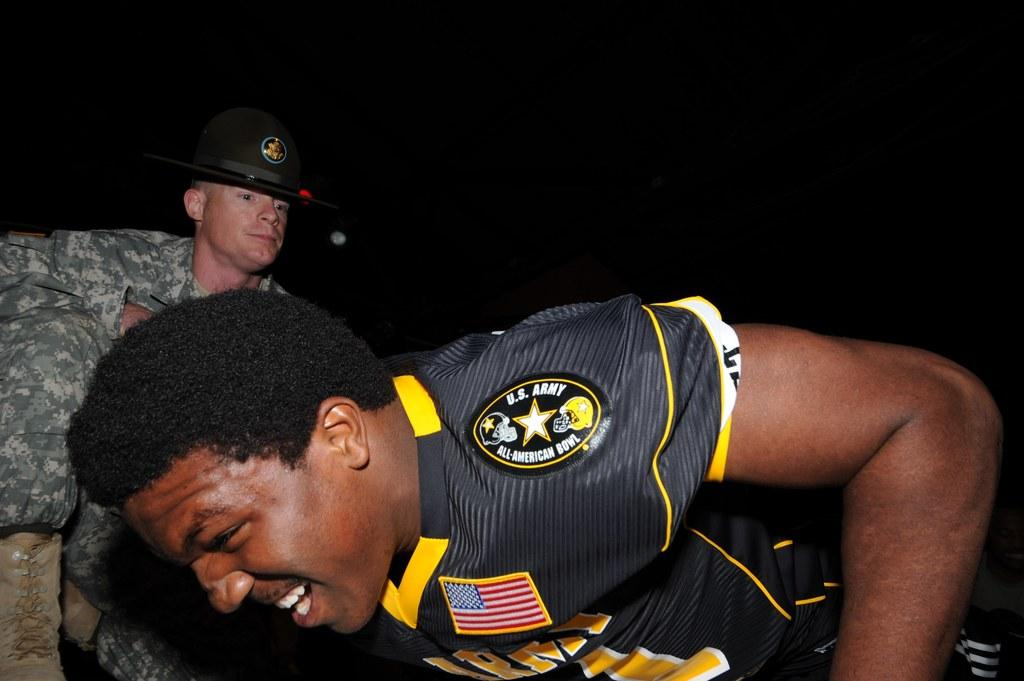<image>
Share a concise interpretation of the image provided. A man leans forward, the words US Army All-American bowl are on his shoulders. 